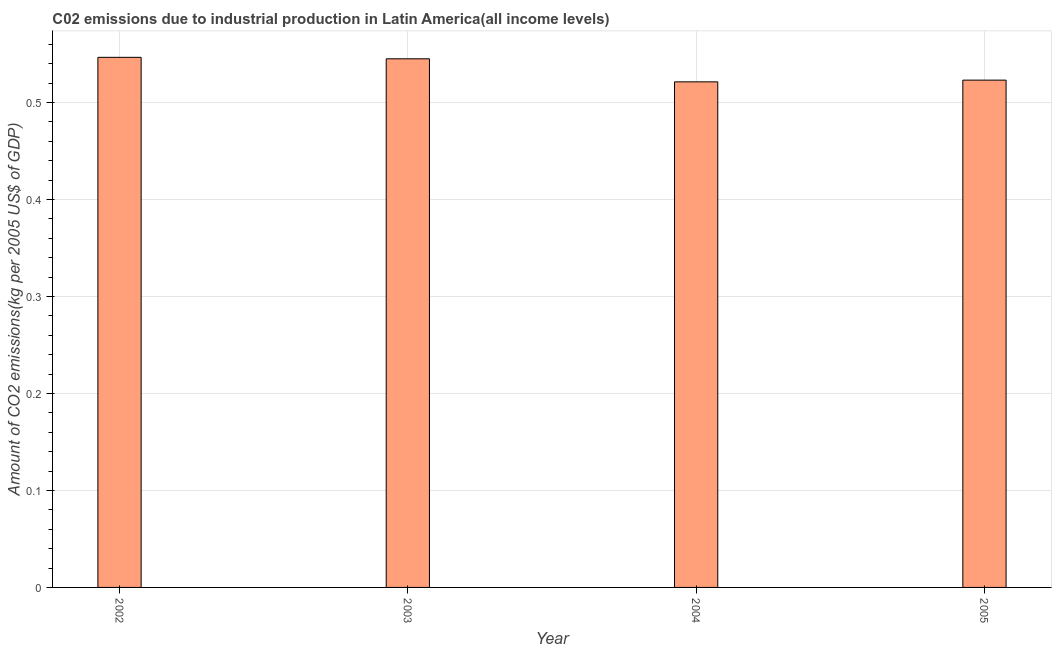Does the graph contain grids?
Your answer should be very brief. Yes. What is the title of the graph?
Provide a short and direct response. C02 emissions due to industrial production in Latin America(all income levels). What is the label or title of the X-axis?
Provide a short and direct response. Year. What is the label or title of the Y-axis?
Provide a succinct answer. Amount of CO2 emissions(kg per 2005 US$ of GDP). What is the amount of co2 emissions in 2003?
Your answer should be compact. 0.55. Across all years, what is the maximum amount of co2 emissions?
Provide a short and direct response. 0.55. Across all years, what is the minimum amount of co2 emissions?
Your answer should be very brief. 0.52. In which year was the amount of co2 emissions maximum?
Offer a very short reply. 2002. What is the sum of the amount of co2 emissions?
Give a very brief answer. 2.14. What is the difference between the amount of co2 emissions in 2004 and 2005?
Your response must be concise. -0. What is the average amount of co2 emissions per year?
Keep it short and to the point. 0.53. What is the median amount of co2 emissions?
Offer a very short reply. 0.53. In how many years, is the amount of co2 emissions greater than 0.04 kg per 2005 US$ of GDP?
Your response must be concise. 4. Do a majority of the years between 2003 and 2005 (inclusive) have amount of co2 emissions greater than 0.34 kg per 2005 US$ of GDP?
Keep it short and to the point. Yes. What is the ratio of the amount of co2 emissions in 2002 to that in 2004?
Ensure brevity in your answer.  1.05. What is the difference between the highest and the second highest amount of co2 emissions?
Keep it short and to the point. 0. Is the sum of the amount of co2 emissions in 2002 and 2003 greater than the maximum amount of co2 emissions across all years?
Provide a succinct answer. Yes. In how many years, is the amount of co2 emissions greater than the average amount of co2 emissions taken over all years?
Ensure brevity in your answer.  2. How many bars are there?
Give a very brief answer. 4. How many years are there in the graph?
Your response must be concise. 4. What is the difference between two consecutive major ticks on the Y-axis?
Make the answer very short. 0.1. Are the values on the major ticks of Y-axis written in scientific E-notation?
Ensure brevity in your answer.  No. What is the Amount of CO2 emissions(kg per 2005 US$ of GDP) in 2002?
Your response must be concise. 0.55. What is the Amount of CO2 emissions(kg per 2005 US$ of GDP) in 2003?
Your response must be concise. 0.55. What is the Amount of CO2 emissions(kg per 2005 US$ of GDP) in 2004?
Keep it short and to the point. 0.52. What is the Amount of CO2 emissions(kg per 2005 US$ of GDP) of 2005?
Offer a terse response. 0.52. What is the difference between the Amount of CO2 emissions(kg per 2005 US$ of GDP) in 2002 and 2003?
Your answer should be very brief. 0. What is the difference between the Amount of CO2 emissions(kg per 2005 US$ of GDP) in 2002 and 2004?
Your response must be concise. 0.03. What is the difference between the Amount of CO2 emissions(kg per 2005 US$ of GDP) in 2002 and 2005?
Your answer should be compact. 0.02. What is the difference between the Amount of CO2 emissions(kg per 2005 US$ of GDP) in 2003 and 2004?
Give a very brief answer. 0.02. What is the difference between the Amount of CO2 emissions(kg per 2005 US$ of GDP) in 2003 and 2005?
Offer a very short reply. 0.02. What is the difference between the Amount of CO2 emissions(kg per 2005 US$ of GDP) in 2004 and 2005?
Keep it short and to the point. -0. What is the ratio of the Amount of CO2 emissions(kg per 2005 US$ of GDP) in 2002 to that in 2004?
Provide a short and direct response. 1.05. What is the ratio of the Amount of CO2 emissions(kg per 2005 US$ of GDP) in 2002 to that in 2005?
Keep it short and to the point. 1.04. What is the ratio of the Amount of CO2 emissions(kg per 2005 US$ of GDP) in 2003 to that in 2004?
Provide a succinct answer. 1.05. What is the ratio of the Amount of CO2 emissions(kg per 2005 US$ of GDP) in 2003 to that in 2005?
Give a very brief answer. 1.04. 